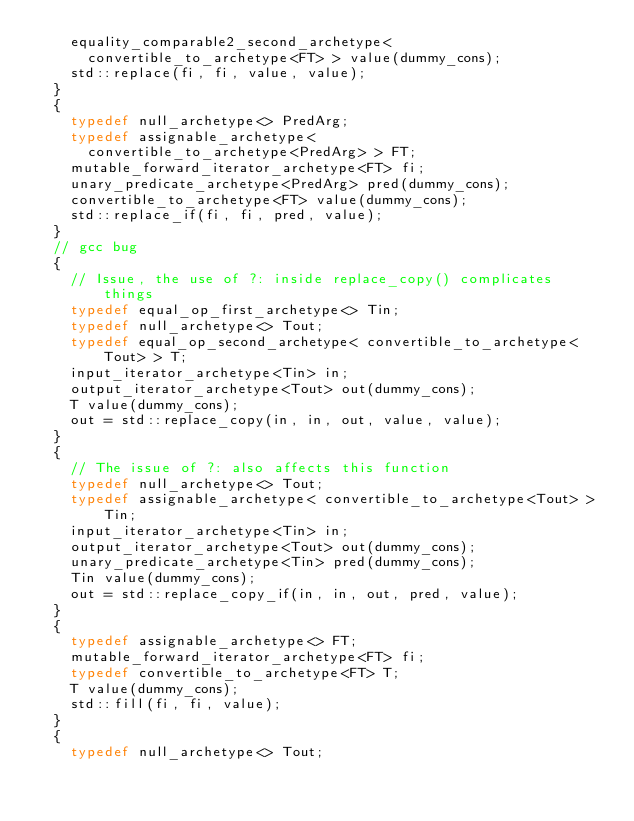<code> <loc_0><loc_0><loc_500><loc_500><_C++_>    equality_comparable2_second_archetype<
      convertible_to_archetype<FT> > value(dummy_cons);
    std::replace(fi, fi, value, value);
  }
  {
    typedef null_archetype<> PredArg;
    typedef assignable_archetype< 
      convertible_to_archetype<PredArg> > FT;
    mutable_forward_iterator_archetype<FT> fi;
    unary_predicate_archetype<PredArg> pred(dummy_cons);
    convertible_to_archetype<FT> value(dummy_cons);
    std::replace_if(fi, fi, pred, value);
  }
  // gcc bug
  {
    // Issue, the use of ?: inside replace_copy() complicates things
    typedef equal_op_first_archetype<> Tin;
    typedef null_archetype<> Tout;
    typedef equal_op_second_archetype< convertible_to_archetype<Tout> > T;
    input_iterator_archetype<Tin> in;
    output_iterator_archetype<Tout> out(dummy_cons);
    T value(dummy_cons);
    out = std::replace_copy(in, in, out, value, value);
  }
  {
    // The issue of ?: also affects this function
    typedef null_archetype<> Tout;
    typedef assignable_archetype< convertible_to_archetype<Tout> > Tin;
    input_iterator_archetype<Tin> in;
    output_iterator_archetype<Tout> out(dummy_cons);
    unary_predicate_archetype<Tin> pred(dummy_cons);
    Tin value(dummy_cons);
    out = std::replace_copy_if(in, in, out, pred, value);
  }
  {
    typedef assignable_archetype<> FT;
    mutable_forward_iterator_archetype<FT> fi;
    typedef convertible_to_archetype<FT> T;
    T value(dummy_cons);
    std::fill(fi, fi, value);
  }  
  {
    typedef null_archetype<> Tout;</code> 